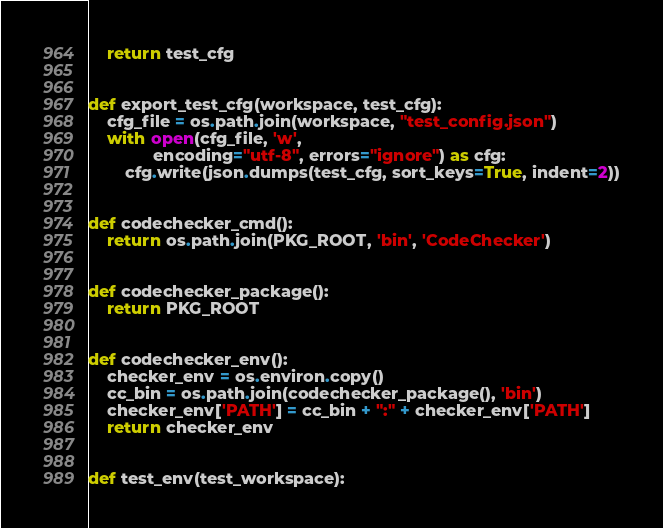Convert code to text. <code><loc_0><loc_0><loc_500><loc_500><_Python_>    return test_cfg


def export_test_cfg(workspace, test_cfg):
    cfg_file = os.path.join(workspace, "test_config.json")
    with open(cfg_file, 'w',
              encoding="utf-8", errors="ignore") as cfg:
        cfg.write(json.dumps(test_cfg, sort_keys=True, indent=2))


def codechecker_cmd():
    return os.path.join(PKG_ROOT, 'bin', 'CodeChecker')


def codechecker_package():
    return PKG_ROOT


def codechecker_env():
    checker_env = os.environ.copy()
    cc_bin = os.path.join(codechecker_package(), 'bin')
    checker_env['PATH'] = cc_bin + ":" + checker_env['PATH']
    return checker_env


def test_env(test_workspace):</code> 